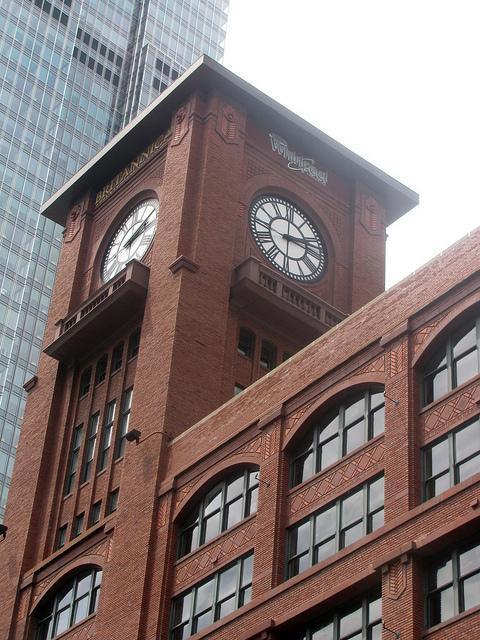How many clocks are there?
Give a very brief answer. 2. How many clock faces do you see?
Give a very brief answer. 2. 